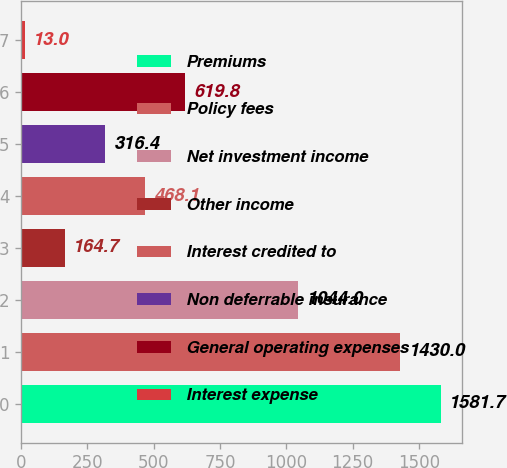Convert chart to OTSL. <chart><loc_0><loc_0><loc_500><loc_500><bar_chart><fcel>Premiums<fcel>Policy fees<fcel>Net investment income<fcel>Other income<fcel>Interest credited to<fcel>Non deferrable insurance<fcel>General operating expenses<fcel>Interest expense<nl><fcel>1581.7<fcel>1430<fcel>1044<fcel>164.7<fcel>468.1<fcel>316.4<fcel>619.8<fcel>13<nl></chart> 